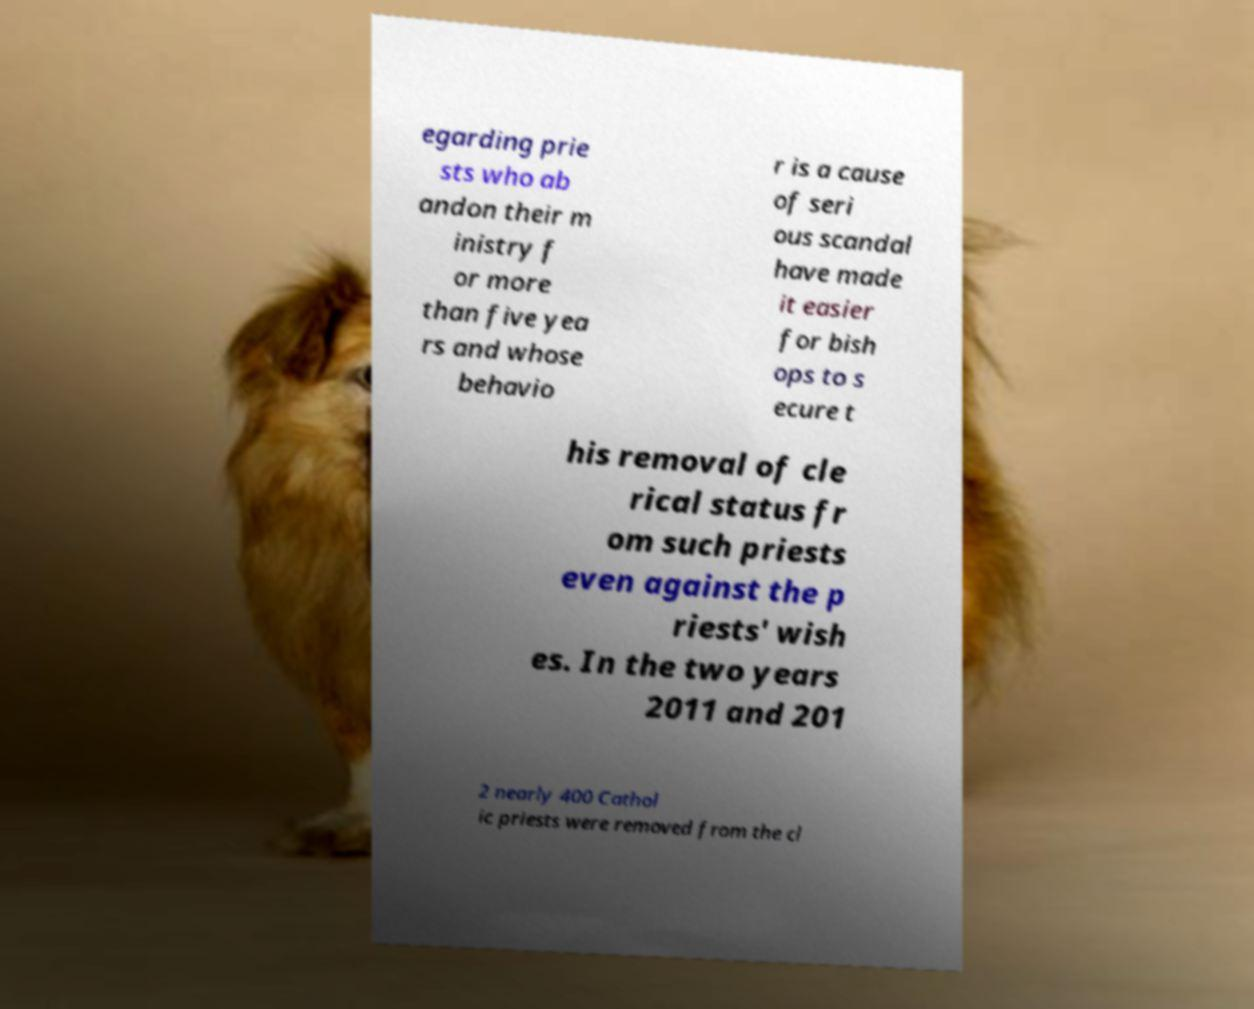Can you accurately transcribe the text from the provided image for me? egarding prie sts who ab andon their m inistry f or more than five yea rs and whose behavio r is a cause of seri ous scandal have made it easier for bish ops to s ecure t his removal of cle rical status fr om such priests even against the p riests' wish es. In the two years 2011 and 201 2 nearly 400 Cathol ic priests were removed from the cl 